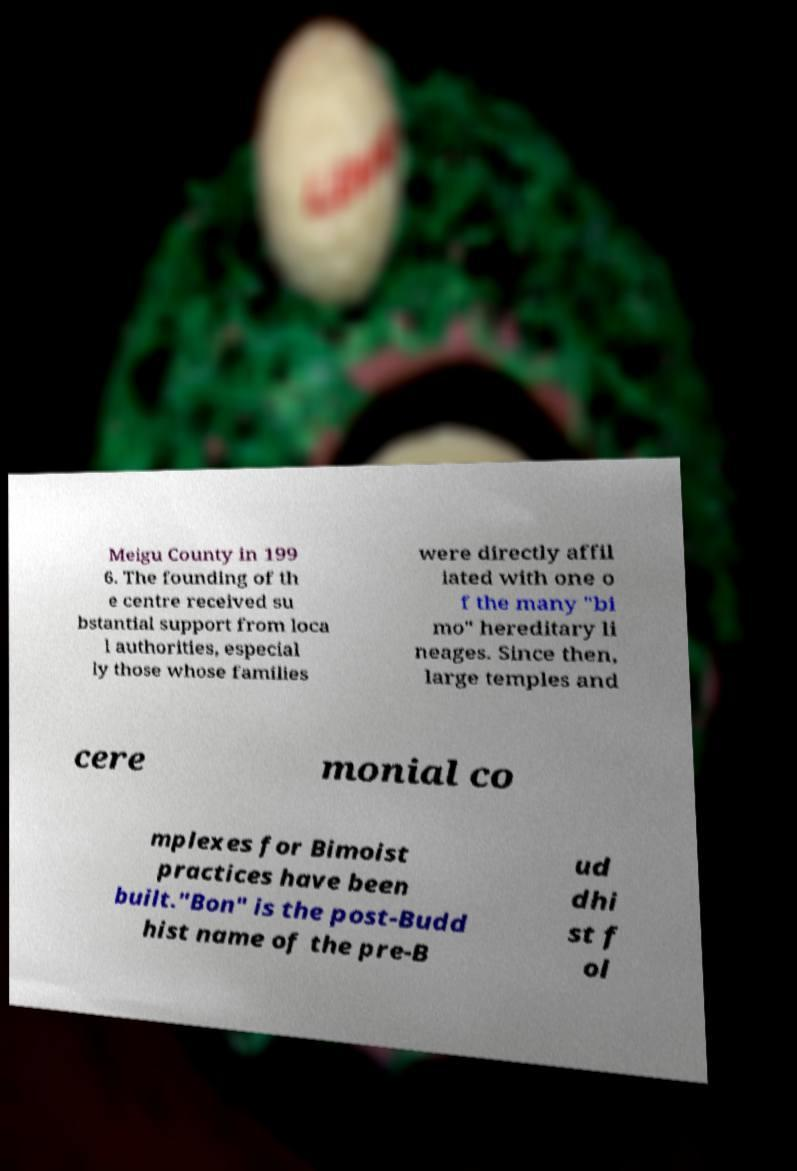Please identify and transcribe the text found in this image. Meigu County in 199 6. The founding of th e centre received su bstantial support from loca l authorities, especial ly those whose families were directly affil iated with one o f the many "bi mo" hereditary li neages. Since then, large temples and cere monial co mplexes for Bimoist practices have been built."Bon" is the post-Budd hist name of the pre-B ud dhi st f ol 